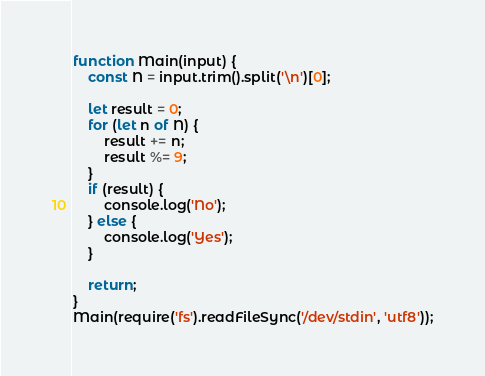<code> <loc_0><loc_0><loc_500><loc_500><_JavaScript_>function Main(input) {
    const N = input.trim().split('\n')[0];

    let result = 0;
    for (let n of N) {
        result += n;
        result %= 9;
    }
    if (result) {
        console.log('No');
    } else {
        console.log('Yes');
    }

    return;
}
Main(require('fs').readFileSync('/dev/stdin', 'utf8'));</code> 